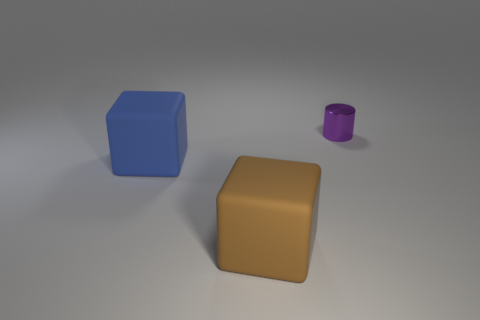Can you infer the scale of these objects? Without a reference point of known size, exact scaling is challenging to infer. However, judging from the proportions and the context provided by the surrounding environment, one might imagine these objects as small to medium-sized, potentially akin to tabletop items. 